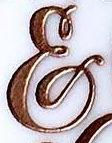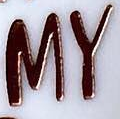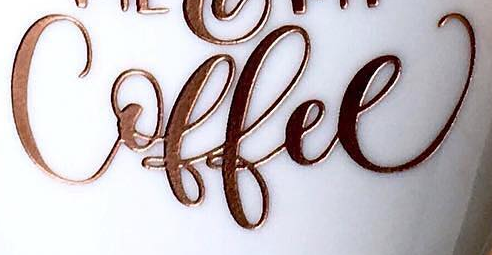What text appears in these images from left to right, separated by a semicolon? &; MY; Coffee 